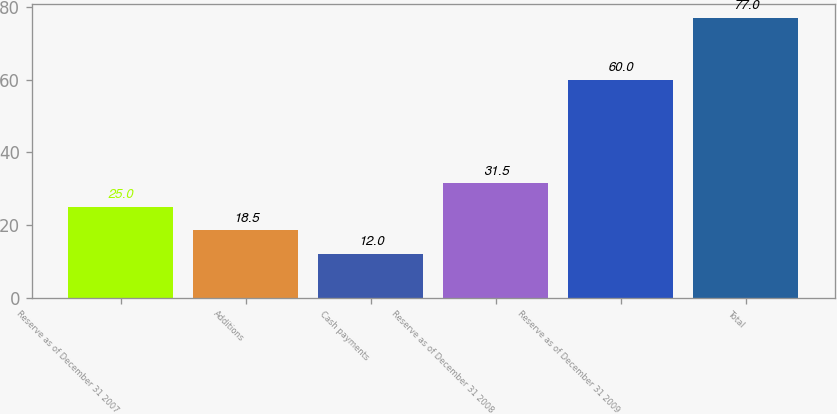Convert chart to OTSL. <chart><loc_0><loc_0><loc_500><loc_500><bar_chart><fcel>Reserve as of December 31 2007<fcel>Additions<fcel>Cash payments<fcel>Reserve as of December 31 2008<fcel>Reserve as of December 31 2009<fcel>Total<nl><fcel>25<fcel>18.5<fcel>12<fcel>31.5<fcel>60<fcel>77<nl></chart> 